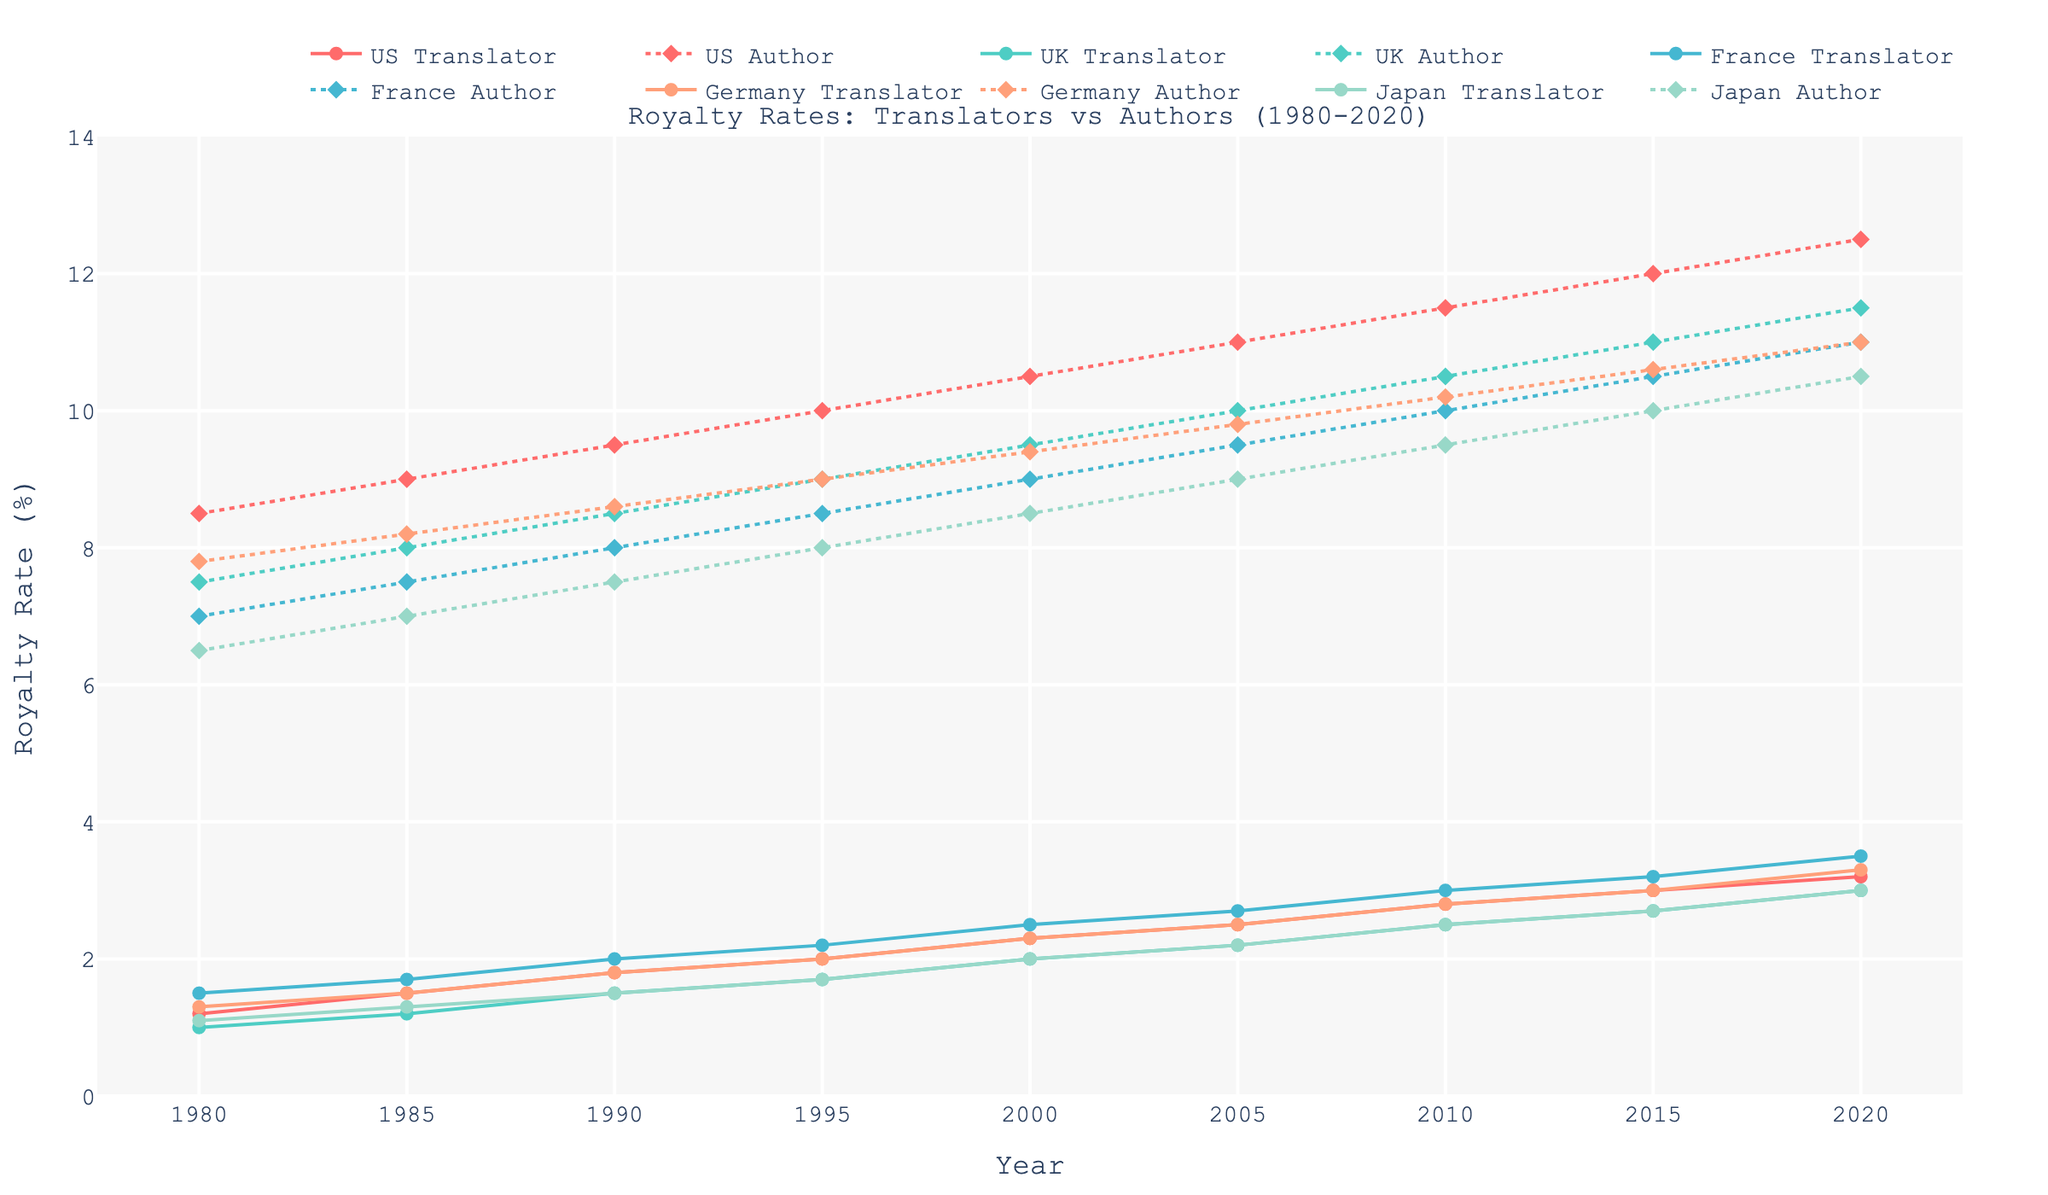What is the highest royalty rate for translators in France over the years? To determine the highest royalty rate for translators in France, we check the plotted line associated with "France Translator". By visually inspecting the peaks, we observe that the line reaches its highest point in 2020 at 3.5%.
Answer: 3.5% How did the royalty rate for authors in the UK change between 1980 and 2020? Observe the "UK Author" line from 1980 to 2020. At the start, the rate is 7.5% and gradually increases, reaching 11.5% in 2020. Compute the difference: 11.5 - 7.5 = 4.0%.
Answer: Increased by 4.0% In which year did authors in Japan surpass a royalty rate of 9%? Inspect the "Japan Author" line and see at what year the values exceed 9%. The line crosses 9% between 2005 and 2010. By 2010, it reached 9.5%. Therefore, 2010 is the answer.
Answer: 2010 What is the average royalty rate for US authors from 1980 to 2020? Collect data points for US authors from the figure: 8.5, 9.0, 9.5, 10.0, 10.5, 11.0, 11.5, 12.0, 12.5. Sum them: (8.5+9.0+9.5+10.0+10.5+11.0+11.5+12.0+12.5) = 94.5. There are 9 data points, so the average is 94.5 / 9 = 10.5%.
Answer: 10.5% What is the royalty rate difference between US authors and translators in 1995? In 1995, the "US Author" rate is 10.0% and "US Translator" rate is 2.0%. Subtract the translator's rate from the author's rate: 10.0 - 2.0 = 8.0%.
Answer: 8.0% Which visual marker represents the UK translators, and what is their color? The "UK Translator" line is spotted by locating the corresponding legend entry. The markers for UK translators are circles, and the color is cyan.
Answer: Circles, cyan 